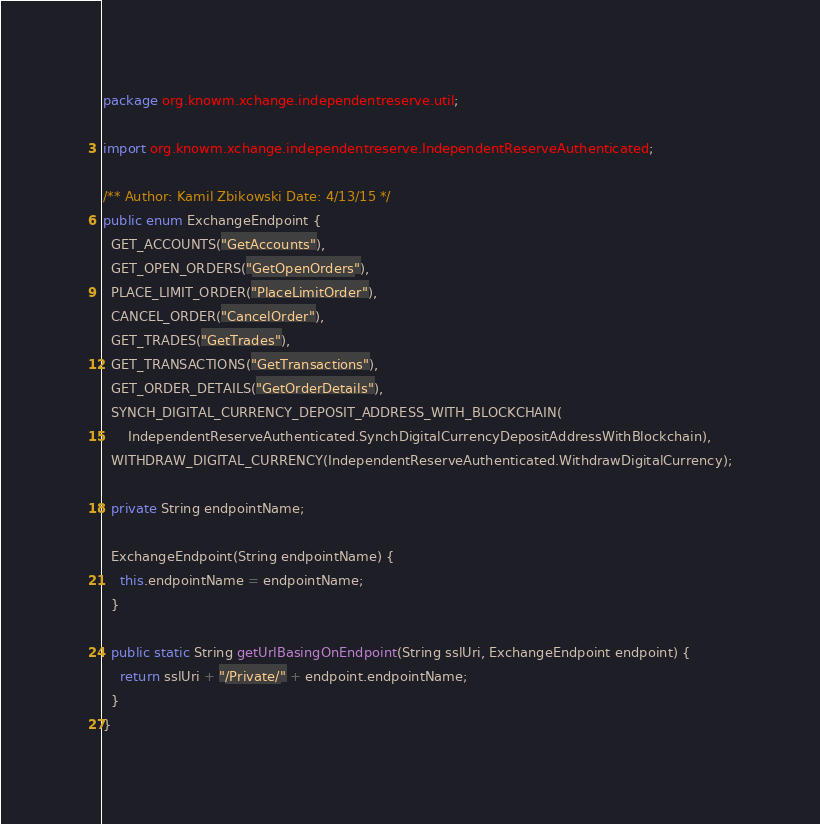<code> <loc_0><loc_0><loc_500><loc_500><_Java_>package org.knowm.xchange.independentreserve.util;

import org.knowm.xchange.independentreserve.IndependentReserveAuthenticated;

/** Author: Kamil Zbikowski Date: 4/13/15 */
public enum ExchangeEndpoint {
  GET_ACCOUNTS("GetAccounts"),
  GET_OPEN_ORDERS("GetOpenOrders"),
  PLACE_LIMIT_ORDER("PlaceLimitOrder"),
  CANCEL_ORDER("CancelOrder"),
  GET_TRADES("GetTrades"),
  GET_TRANSACTIONS("GetTransactions"),
  GET_ORDER_DETAILS("GetOrderDetails"),
  SYNCH_DIGITAL_CURRENCY_DEPOSIT_ADDRESS_WITH_BLOCKCHAIN(
      IndependentReserveAuthenticated.SynchDigitalCurrencyDepositAddressWithBlockchain),
  WITHDRAW_DIGITAL_CURRENCY(IndependentReserveAuthenticated.WithdrawDigitalCurrency);

  private String endpointName;

  ExchangeEndpoint(String endpointName) {
    this.endpointName = endpointName;
  }

  public static String getUrlBasingOnEndpoint(String sslUri, ExchangeEndpoint endpoint) {
    return sslUri + "/Private/" + endpoint.endpointName;
  }
}
</code> 